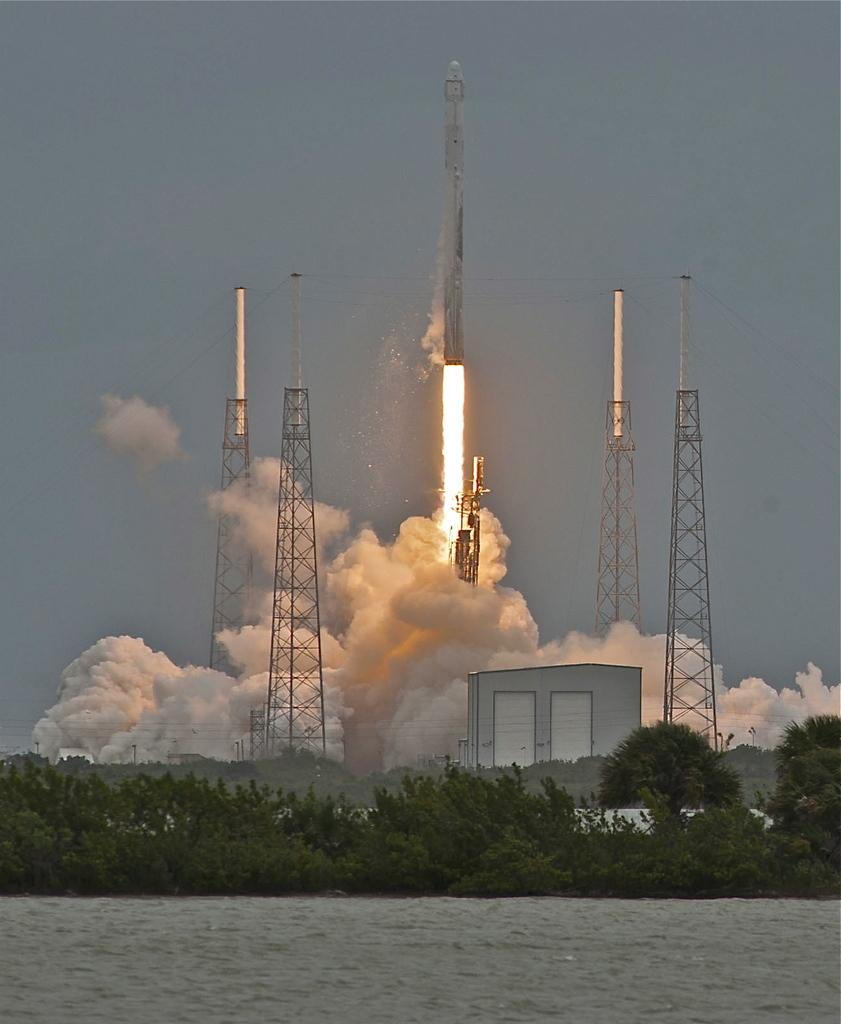What is present in the image that is not solid? There is water in the image. What type of natural elements can be seen in the image? There are trees in the image. What man-made structures are visible in the image? There are buildings and towers in the image. What unusual object can be seen in the image? There is a rocket in the image. What is visible at the top of the image? The sky is visible at the top of the image. Can you tell me how many gates are present in the image? There are no gates present in the image. What advice does the grandmother give in the image? There is no grandmother present in the image, so it is not possible to answer that question. 